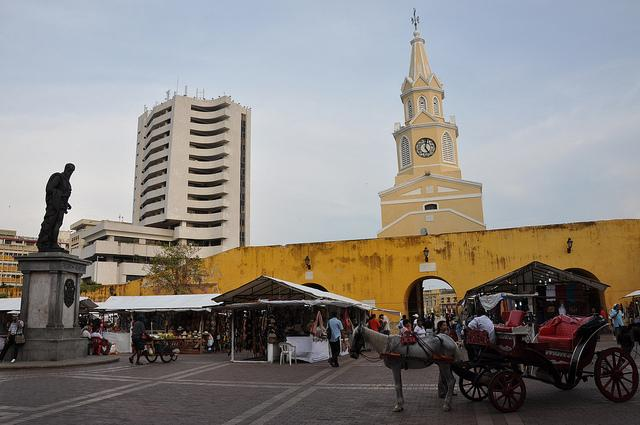Which structure was put up most recently?

Choices:
A) high rise
B) tent
C) clock tower
D) statue tent 